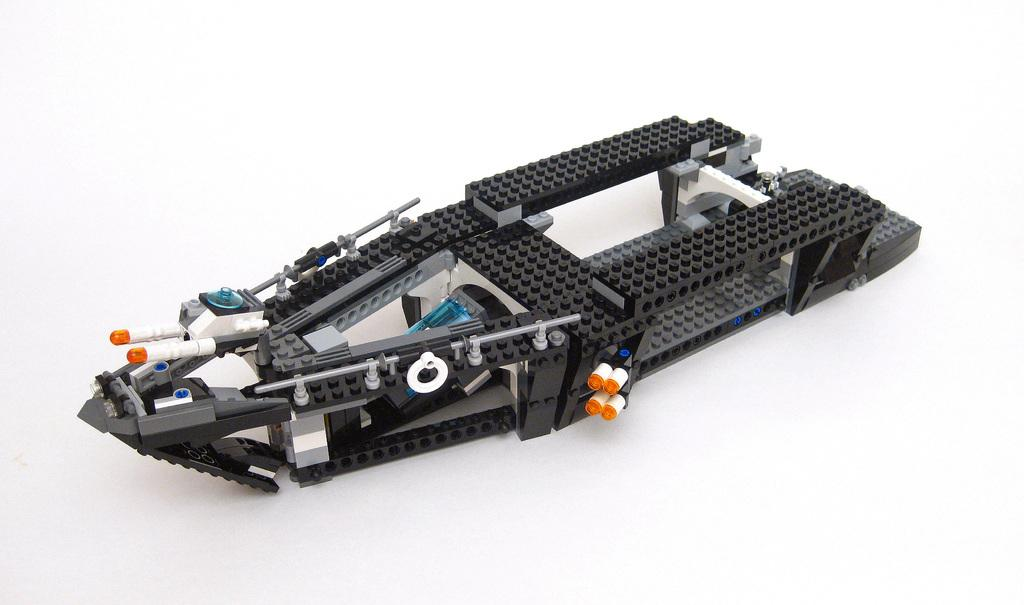What type of toy is present in the image? There is a building blocks toy in the image. What is the color of the surface on which the toy is placed? The building blocks toy is placed on a white surface. What type of humor does the governor use in the image? There is no governor present in the image, and therefore no humor can be observed. Can you tell me how many needles are used to create the building blocks toy in the image? The building blocks toy is not made of needles; it is likely made of plastic or wood. 